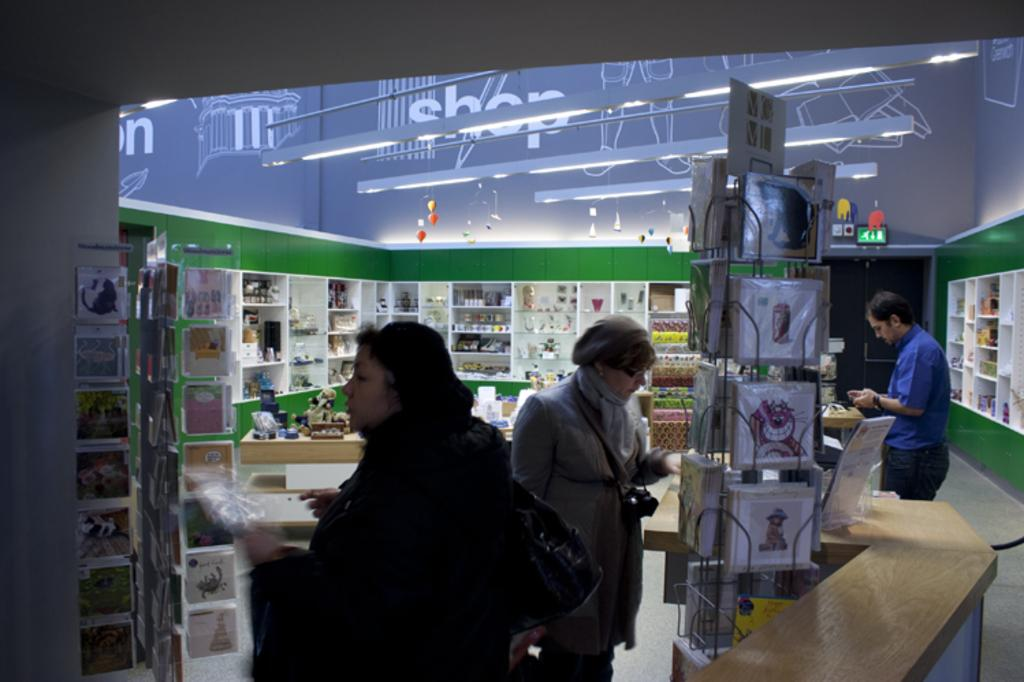<image>
Give a short and clear explanation of the subsequent image. The word "shop" can be seen on the wall above the lights 